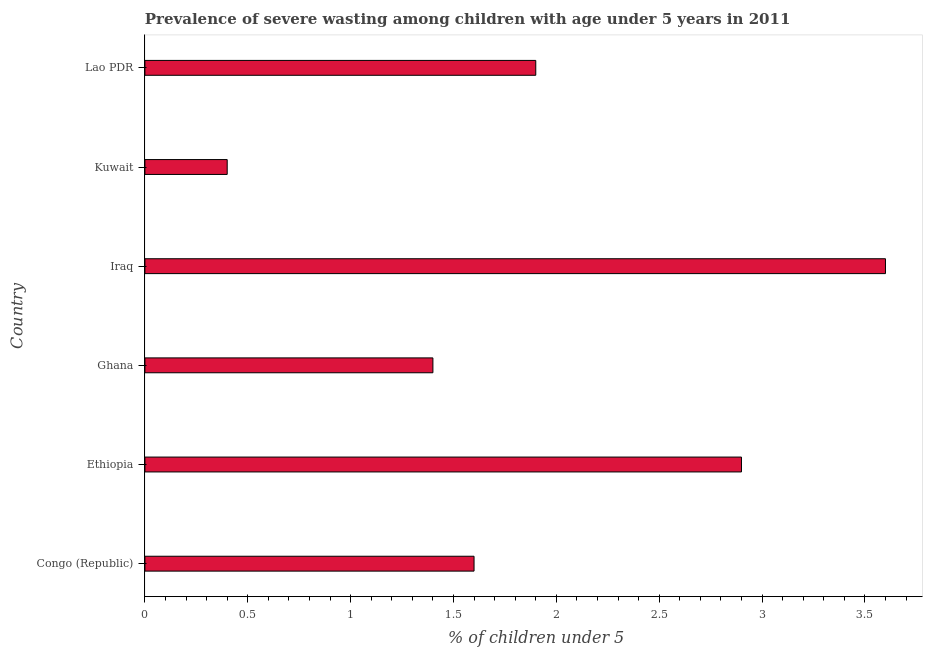What is the title of the graph?
Offer a very short reply. Prevalence of severe wasting among children with age under 5 years in 2011. What is the label or title of the X-axis?
Your answer should be compact.  % of children under 5. What is the label or title of the Y-axis?
Your answer should be compact. Country. What is the prevalence of severe wasting in Congo (Republic)?
Provide a succinct answer. 1.6. Across all countries, what is the maximum prevalence of severe wasting?
Offer a very short reply. 3.6. Across all countries, what is the minimum prevalence of severe wasting?
Provide a succinct answer. 0.4. In which country was the prevalence of severe wasting maximum?
Provide a short and direct response. Iraq. In which country was the prevalence of severe wasting minimum?
Provide a short and direct response. Kuwait. What is the sum of the prevalence of severe wasting?
Provide a short and direct response. 11.8. What is the average prevalence of severe wasting per country?
Offer a terse response. 1.97. What is the ratio of the prevalence of severe wasting in Congo (Republic) to that in Lao PDR?
Make the answer very short. 0.84. Are all the bars in the graph horizontal?
Give a very brief answer. Yes. What is the  % of children under 5 in Congo (Republic)?
Give a very brief answer. 1.6. What is the  % of children under 5 in Ethiopia?
Provide a succinct answer. 2.9. What is the  % of children under 5 of Ghana?
Make the answer very short. 1.4. What is the  % of children under 5 in Iraq?
Your answer should be very brief. 3.6. What is the  % of children under 5 of Kuwait?
Keep it short and to the point. 0.4. What is the  % of children under 5 of Lao PDR?
Provide a short and direct response. 1.9. What is the difference between the  % of children under 5 in Congo (Republic) and Ethiopia?
Your answer should be compact. -1.3. What is the difference between the  % of children under 5 in Congo (Republic) and Ghana?
Keep it short and to the point. 0.2. What is the difference between the  % of children under 5 in Congo (Republic) and Iraq?
Give a very brief answer. -2. What is the difference between the  % of children under 5 in Congo (Republic) and Kuwait?
Your answer should be compact. 1.2. What is the difference between the  % of children under 5 in Ethiopia and Iraq?
Your answer should be compact. -0.7. What is the difference between the  % of children under 5 in Ethiopia and Kuwait?
Give a very brief answer. 2.5. What is the difference between the  % of children under 5 in Ghana and Iraq?
Ensure brevity in your answer.  -2.2. What is the difference between the  % of children under 5 in Ghana and Kuwait?
Your answer should be very brief. 1. What is the difference between the  % of children under 5 in Ghana and Lao PDR?
Offer a very short reply. -0.5. What is the difference between the  % of children under 5 in Kuwait and Lao PDR?
Ensure brevity in your answer.  -1.5. What is the ratio of the  % of children under 5 in Congo (Republic) to that in Ethiopia?
Your response must be concise. 0.55. What is the ratio of the  % of children under 5 in Congo (Republic) to that in Ghana?
Your answer should be very brief. 1.14. What is the ratio of the  % of children under 5 in Congo (Republic) to that in Iraq?
Your answer should be compact. 0.44. What is the ratio of the  % of children under 5 in Congo (Republic) to that in Lao PDR?
Provide a short and direct response. 0.84. What is the ratio of the  % of children under 5 in Ethiopia to that in Ghana?
Offer a terse response. 2.07. What is the ratio of the  % of children under 5 in Ethiopia to that in Iraq?
Your answer should be compact. 0.81. What is the ratio of the  % of children under 5 in Ethiopia to that in Kuwait?
Make the answer very short. 7.25. What is the ratio of the  % of children under 5 in Ethiopia to that in Lao PDR?
Provide a short and direct response. 1.53. What is the ratio of the  % of children under 5 in Ghana to that in Iraq?
Your answer should be compact. 0.39. What is the ratio of the  % of children under 5 in Ghana to that in Lao PDR?
Provide a short and direct response. 0.74. What is the ratio of the  % of children under 5 in Iraq to that in Lao PDR?
Offer a very short reply. 1.9. What is the ratio of the  % of children under 5 in Kuwait to that in Lao PDR?
Ensure brevity in your answer.  0.21. 